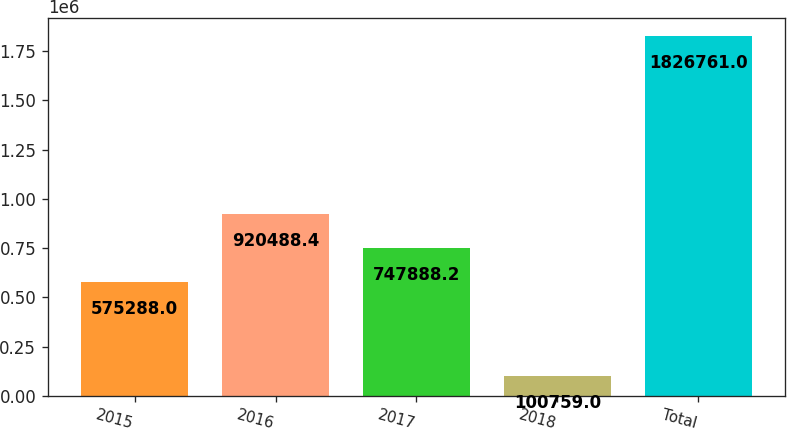<chart> <loc_0><loc_0><loc_500><loc_500><bar_chart><fcel>2015<fcel>2016<fcel>2017<fcel>2018<fcel>Total<nl><fcel>575288<fcel>920488<fcel>747888<fcel>100759<fcel>1.82676e+06<nl></chart> 